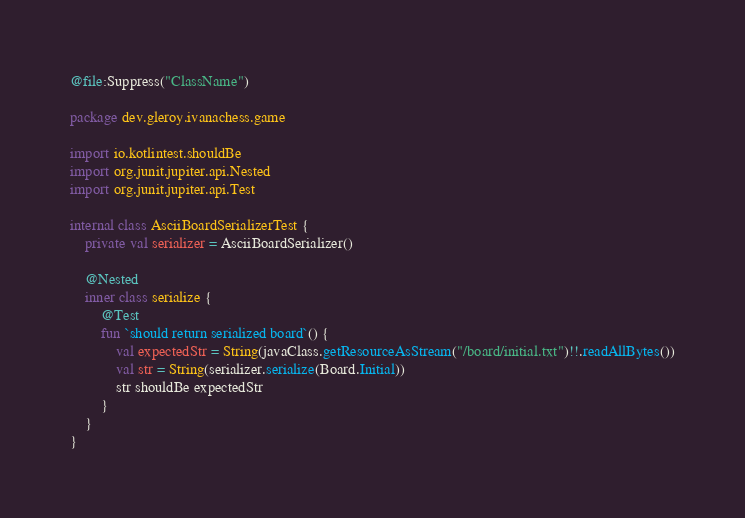Convert code to text. <code><loc_0><loc_0><loc_500><loc_500><_Kotlin_>@file:Suppress("ClassName")

package dev.gleroy.ivanachess.game

import io.kotlintest.shouldBe
import org.junit.jupiter.api.Nested
import org.junit.jupiter.api.Test

internal class AsciiBoardSerializerTest {
    private val serializer = AsciiBoardSerializer()

    @Nested
    inner class serialize {
        @Test
        fun `should return serialized board`() {
            val expectedStr = String(javaClass.getResourceAsStream("/board/initial.txt")!!.readAllBytes())
            val str = String(serializer.serialize(Board.Initial))
            str shouldBe expectedStr
        }
    }
}
</code> 